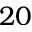Convert formula to latex. <formula><loc_0><loc_0><loc_500><loc_500>2 0</formula> 